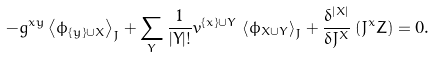<formula> <loc_0><loc_0><loc_500><loc_500>- g ^ { x y } \left \langle \phi _ { \left \{ y \right \} \cup X } \right \rangle _ { J } + \sum _ { Y } \frac { 1 } { | Y | ! } v ^ { \left \{ x \right \} \cup Y } \, \left \langle \phi _ { X \cup Y } \right \rangle _ { J } + \frac { \delta ^ { | X | } } { \delta J ^ { X } } \left ( J ^ { x } Z \right ) = 0 .</formula> 